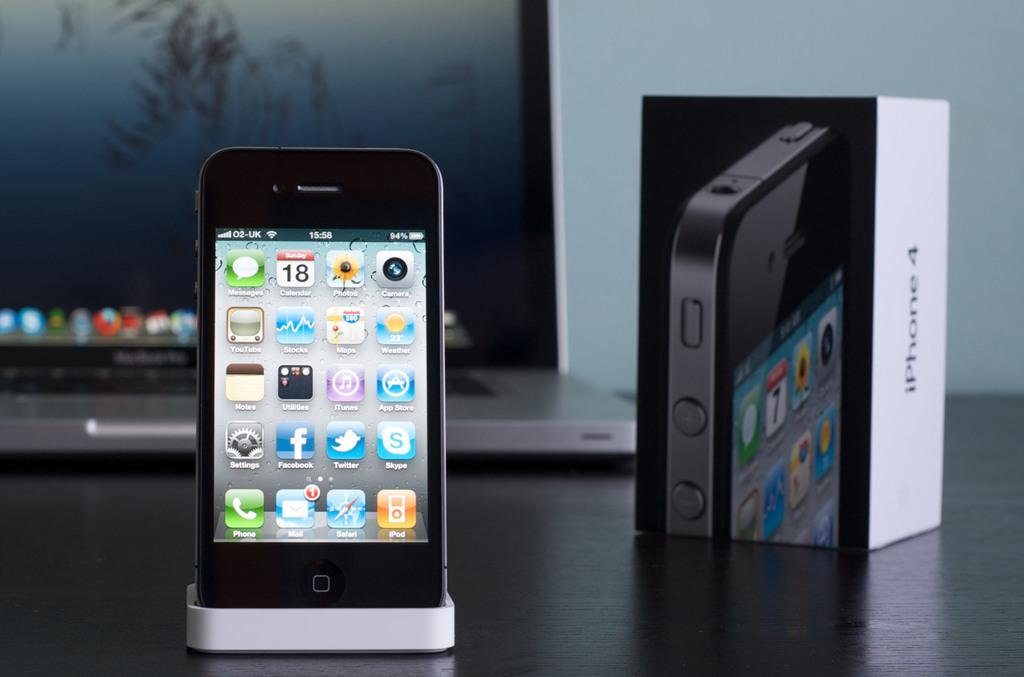<image>
Summarize the visual content of the image. an icon is on a phone that says Facebook 